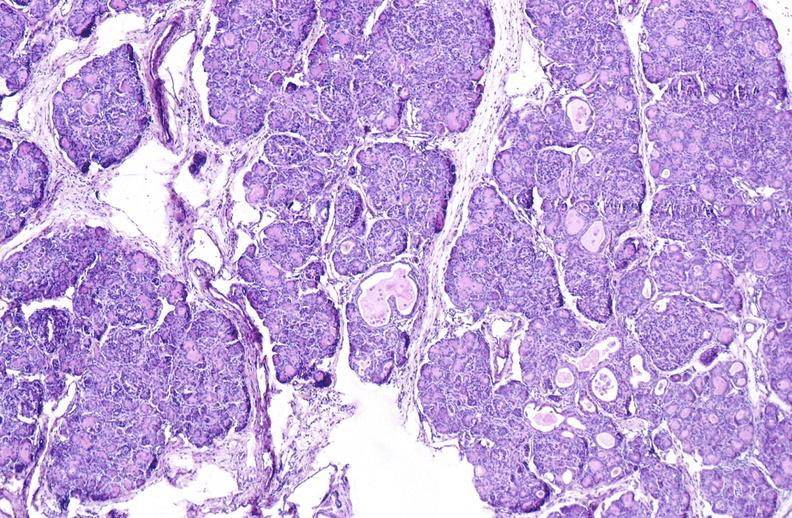does very good example show cystic fibrosis?
Answer the question using a single word or phrase. No 